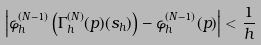<formula> <loc_0><loc_0><loc_500><loc_500>\left | \varphi ^ { ( N - 1 ) } _ { h } \left ( \Gamma ^ { ( N ) } _ { h } ( p ) ( s _ { h } ) \right ) - \varphi ^ { ( N - 1 ) } _ { h } ( p ) \right | < \frac { 1 } { h }</formula> 